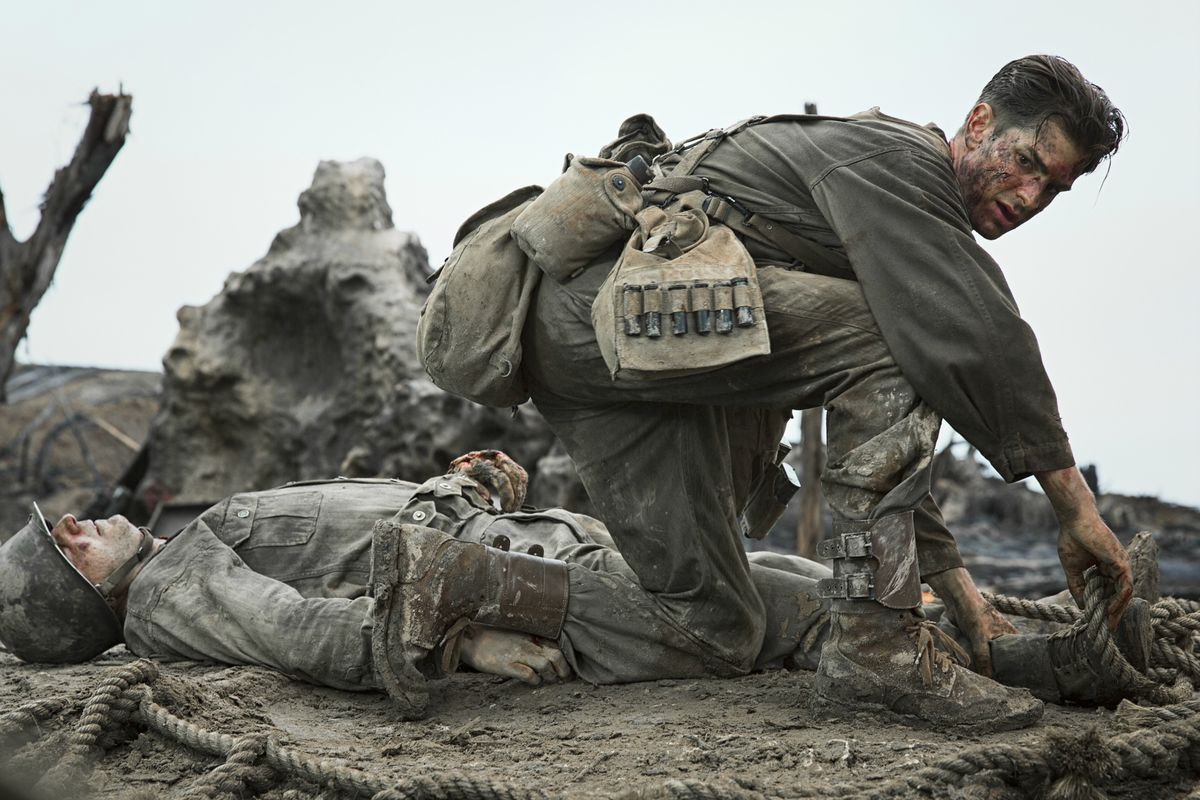If you could ask Desmond Doss a question about his experience, what would it be? Desmond, what keeps you motivated and focused in the face of such overwhelming danger and adversity? How does Desmond keep track of all his medical supplies in such a chaotic environment? Desmond likely keeps track of his medical supplies through meticulous organization and discipline. He would have a mental inventory of what each compartment or pocket of his backpack contains and prioritize essential items for quick access. In such chaotic environments, every second counts, so having an efficient system becomes crucial. Training, experience, and muscle memory also play significant roles in ensuring he can find what he needs under pressure. Can you describe a hypothetical situation where Desmond might have to make a quick decision under fire? Imagine Desmond is in the middle of a relentless firefight on the battlefield. He spots a severely wounded soldier lying exposed in an open area. Bullets are whizzing by as he quickly assesses the situation. Desmond knows that moving the soldier is imperative to provide medical aid, but doing so openly would expose them both to enemy fire. He decides to use a nearby trench as cover, crawling and maneuvering under minimal shelter. With every second counting, Desmond reaches the soldier, applies a tourniquet to stem the bleeding, and drags him to the relative safety of the trench. All the while, his heart races, but his focus remains unwavering – a testament to his quick thinking and bravery. In a fantastical twist, what if Desmond had a magical item to help him on the battlefield? If Desmond had a magical item, it could be something extraordinary like a 'Healing Amulet'. This amulet, when touched to a wounded soldier, instantly heals their injuries and revitalizes their strength. The amulet's power is fueled by Desmond's unwavering compassion and determination. During the fiercest battles, the amulet glows with an ethereal light, guiding Desmond to the soldiers who need him the most. This fantastical element would add a layer of hope and wonder to the grim realities of war, highlighting the theme of miraculous bravery in the midst of adversity. 